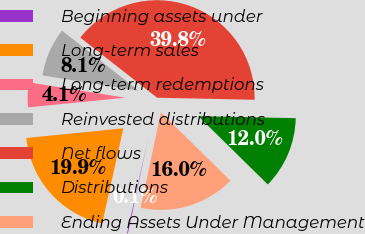<chart> <loc_0><loc_0><loc_500><loc_500><pie_chart><fcel>Beginning assets under<fcel>Long-term sales<fcel>Long-term redemptions<fcel>Reinvested distributions<fcel>Net flows<fcel>Distributions<fcel>Ending Assets Under Management<nl><fcel>0.14%<fcel>19.94%<fcel>4.1%<fcel>8.06%<fcel>39.75%<fcel>12.02%<fcel>15.98%<nl></chart> 